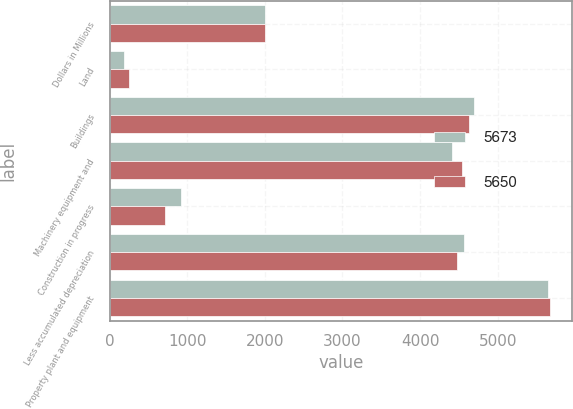Convert chart. <chart><loc_0><loc_0><loc_500><loc_500><stacked_bar_chart><ecel><fcel>Dollars in Millions<fcel>Land<fcel>Buildings<fcel>Machinery equipment and<fcel>Construction in progress<fcel>Less accumulated depreciation<fcel>Property plant and equipment<nl><fcel>5673<fcel>2007<fcel>185<fcel>4696<fcel>4418<fcel>915<fcel>4564<fcel>5650<nl><fcel>5650<fcel>2006<fcel>254<fcel>4630<fcel>4540<fcel>720<fcel>4471<fcel>5673<nl></chart> 